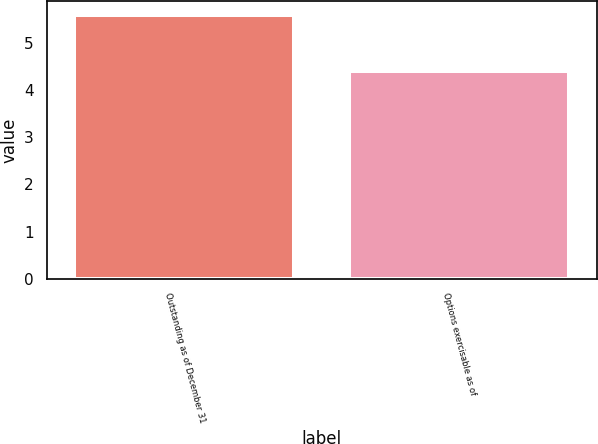Convert chart to OTSL. <chart><loc_0><loc_0><loc_500><loc_500><bar_chart><fcel>Outstanding as of December 31<fcel>Options exercisable as of<nl><fcel>5.6<fcel>4.4<nl></chart> 